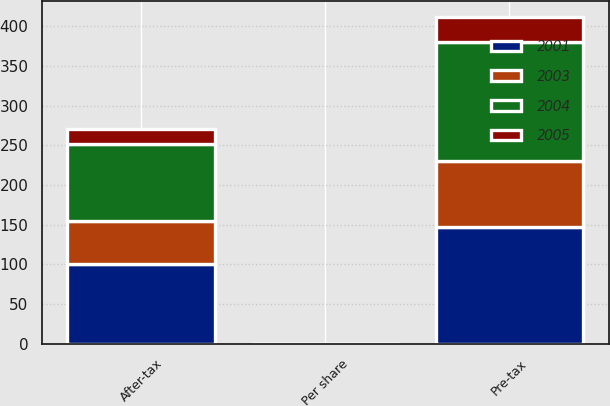Convert chart. <chart><loc_0><loc_0><loc_500><loc_500><stacked_bar_chart><ecel><fcel>Pre-tax<fcel>After-tax<fcel>Per share<nl><fcel>2003<fcel>83<fcel>55<fcel>0.03<nl><fcel>2004<fcel>150<fcel>96<fcel>0.06<nl><fcel>2001<fcel>147<fcel>100<fcel>0.06<nl><fcel>2005<fcel>31<fcel>19<fcel>0.01<nl></chart> 